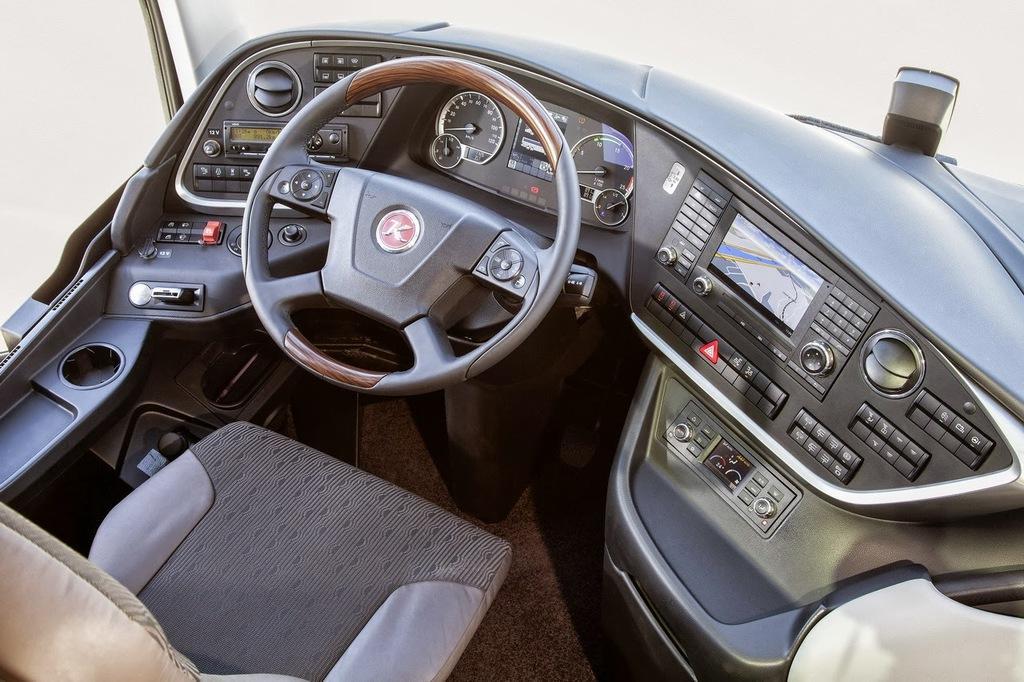Please provide a concise description of this image. This is an inside view of a vehicle. We can see steering, buttons, seat, gauges, screen and some objects. 